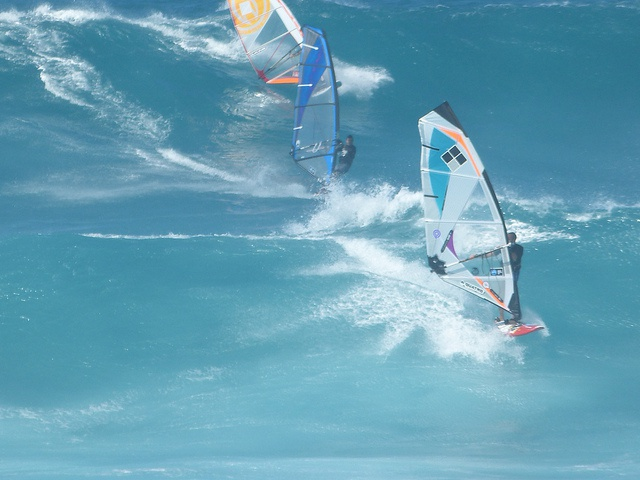Describe the objects in this image and their specific colors. I can see surfboard in teal, gray, lightblue, and darkgray tones, people in teal, gray, and blue tones, people in teal, blue, and gray tones, and surfboard in teal, lightgray, darkgray, salmon, and lightpink tones in this image. 